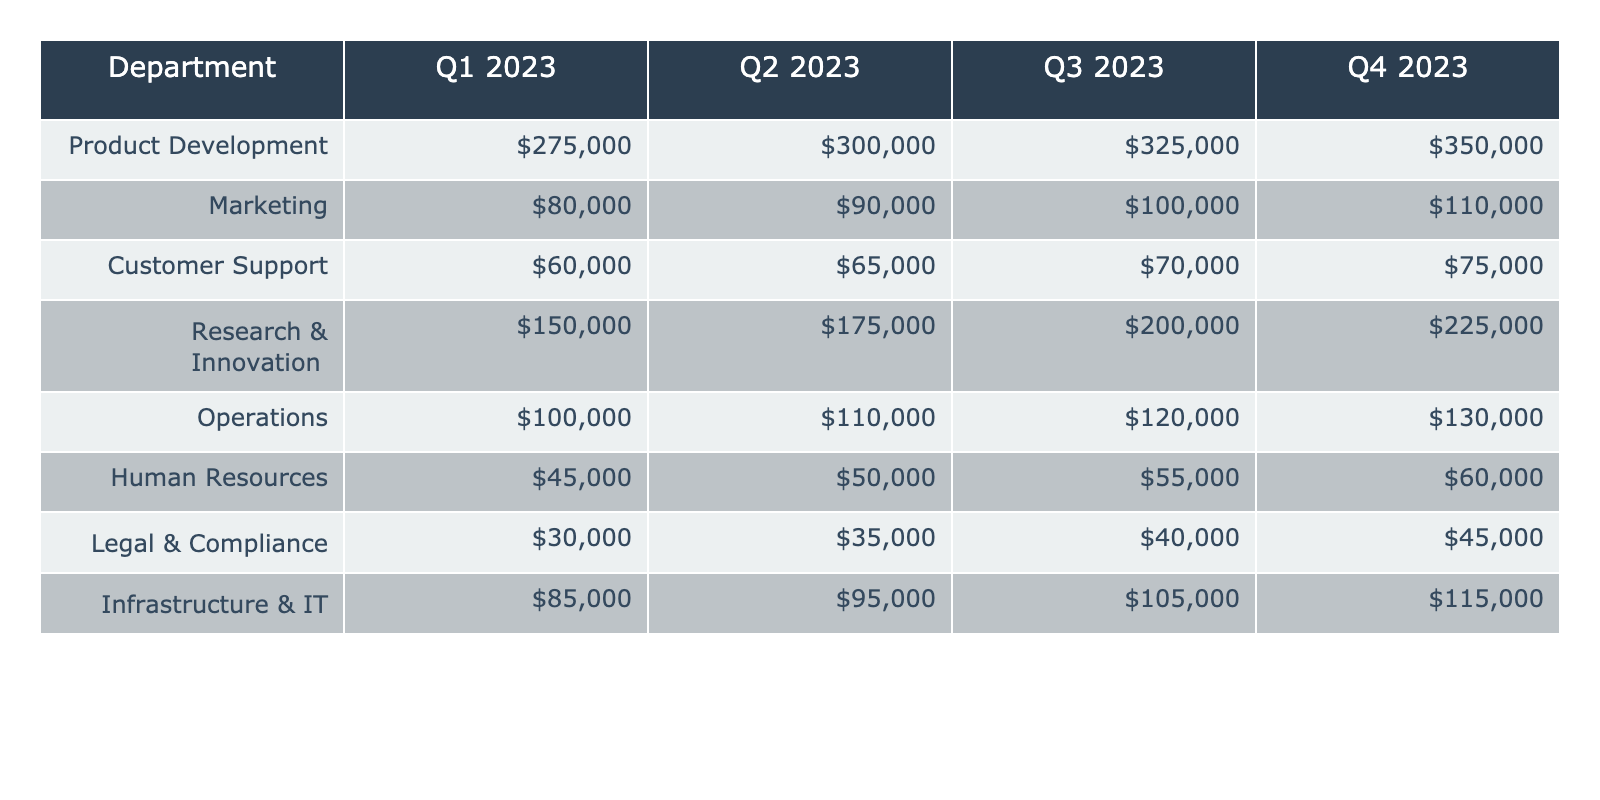What was the funding allocation for Product Development in Q3 2023? The table shows the funding allocation for Product Development in each quarter. For Q3 2023, the value listed is 325,000.
Answer: 325000 Which department received the highest allocation in Q4 2023? By examining the values in the Q4 2023 column for each department, Product Development has the highest allocation at 350,000.
Answer: Product Development What is the total funding allocated to Customer Support across all quarters? To find the total funding for Customer Support, we sum the values for each quarter: 60,000 + 65,000 + 70,000 + 75,000 = 270,000.
Answer: 270000 How much more funding does Research & Innovation receive than Human Resources in Q2 2023? In Q2 2023, Research & Innovation received 175,000 while Human Resources received 50,000. The difference is 175,000 - 50,000 = 125,000.
Answer: 125000 Is the funding for Marketing consistently increasing over the quarters? By reviewing the Q1 to Q4 values for Marketing (80,000, 90,000, 100,000, 110,000), each value is greater than the previous, indicating a consistent increase.
Answer: Yes What was the average funding allocated to Operations over the four quarters? To calculate the average for Operations, sum the values: 100,000 + 110,000 + 120,000 + 130,000 = 460,000, and divide by 4. The average is 460,000 / 4 = 115,000.
Answer: 115000 Which department had the lowest overall funding across all quarters? Comparing the total allocations for each department, Human Resources has the lowest total of 45,000 + 50,000 + 55,000 + 60,000 = 210,000.
Answer: Human Resources What is the difference in funding between Infrastructure & IT and Legal & Compliance in Q1 2023? In Q1 2023, Infrastructure & IT received 85,000 and Legal & Compliance received 30,000. The difference is 85,000 - 30,000 = 55,000.
Answer: 55000 How much funding is allocated to Marketing in Q3 2023 compared to Operations in Q4 2023? For Marketing in Q3 2023, the funding is 100,000, and for Operations in Q4 2023, it is 130,000. The difference is 130,000 - 100,000 = 30,000 more for Operations.
Answer: 30,000 more for Operations What percentage increase in funding is observed for Research & Innovation from Q1 2023 to Q4 2023? The funding for Research & Innovation changes from 150,000 in Q1 to 225,000 in Q4. The increase is 225,000 - 150,000 = 75,000. The percentage increase is (75,000 / 150,000) * 100 = 50%.
Answer: 50% 